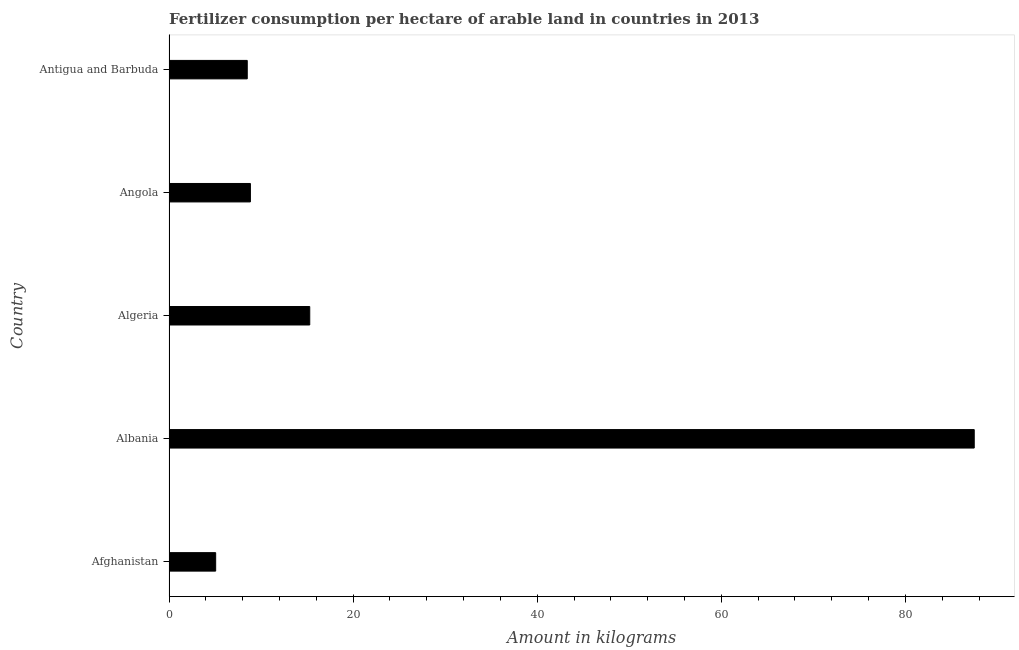Does the graph contain any zero values?
Provide a succinct answer. No. Does the graph contain grids?
Keep it short and to the point. No. What is the title of the graph?
Your answer should be compact. Fertilizer consumption per hectare of arable land in countries in 2013 . What is the label or title of the X-axis?
Ensure brevity in your answer.  Amount in kilograms. What is the amount of fertilizer consumption in Angola?
Your answer should be compact. 8.84. Across all countries, what is the maximum amount of fertilizer consumption?
Your answer should be very brief. 87.48. Across all countries, what is the minimum amount of fertilizer consumption?
Provide a succinct answer. 5.07. In which country was the amount of fertilizer consumption maximum?
Your answer should be very brief. Albania. In which country was the amount of fertilizer consumption minimum?
Give a very brief answer. Afghanistan. What is the sum of the amount of fertilizer consumption?
Make the answer very short. 125.18. What is the difference between the amount of fertilizer consumption in Albania and Angola?
Ensure brevity in your answer.  78.63. What is the average amount of fertilizer consumption per country?
Ensure brevity in your answer.  25.04. What is the median amount of fertilizer consumption?
Your answer should be compact. 8.84. In how many countries, is the amount of fertilizer consumption greater than 44 kg?
Offer a very short reply. 1. What is the ratio of the amount of fertilizer consumption in Afghanistan to that in Angola?
Give a very brief answer. 0.57. What is the difference between the highest and the second highest amount of fertilizer consumption?
Give a very brief answer. 72.19. What is the difference between the highest and the lowest amount of fertilizer consumption?
Offer a terse response. 82.41. In how many countries, is the amount of fertilizer consumption greater than the average amount of fertilizer consumption taken over all countries?
Your response must be concise. 1. How many bars are there?
Offer a terse response. 5. Are all the bars in the graph horizontal?
Provide a succinct answer. Yes. How many countries are there in the graph?
Provide a short and direct response. 5. What is the difference between two consecutive major ticks on the X-axis?
Offer a terse response. 20. Are the values on the major ticks of X-axis written in scientific E-notation?
Give a very brief answer. No. What is the Amount in kilograms of Afghanistan?
Keep it short and to the point. 5.07. What is the Amount in kilograms of Albania?
Provide a succinct answer. 87.48. What is the Amount in kilograms of Algeria?
Your answer should be very brief. 15.29. What is the Amount in kilograms of Angola?
Offer a very short reply. 8.84. What is the Amount in kilograms in Antigua and Barbuda?
Provide a short and direct response. 8.5. What is the difference between the Amount in kilograms in Afghanistan and Albania?
Ensure brevity in your answer.  -82.41. What is the difference between the Amount in kilograms in Afghanistan and Algeria?
Your answer should be compact. -10.22. What is the difference between the Amount in kilograms in Afghanistan and Angola?
Keep it short and to the point. -3.77. What is the difference between the Amount in kilograms in Afghanistan and Antigua and Barbuda?
Give a very brief answer. -3.43. What is the difference between the Amount in kilograms in Albania and Algeria?
Give a very brief answer. 72.19. What is the difference between the Amount in kilograms in Albania and Angola?
Your answer should be compact. 78.63. What is the difference between the Amount in kilograms in Albania and Antigua and Barbuda?
Your answer should be very brief. 78.98. What is the difference between the Amount in kilograms in Algeria and Angola?
Your answer should be very brief. 6.45. What is the difference between the Amount in kilograms in Algeria and Antigua and Barbuda?
Your answer should be compact. 6.79. What is the difference between the Amount in kilograms in Angola and Antigua and Barbuda?
Offer a terse response. 0.34. What is the ratio of the Amount in kilograms in Afghanistan to that in Albania?
Your response must be concise. 0.06. What is the ratio of the Amount in kilograms in Afghanistan to that in Algeria?
Your answer should be very brief. 0.33. What is the ratio of the Amount in kilograms in Afghanistan to that in Angola?
Keep it short and to the point. 0.57. What is the ratio of the Amount in kilograms in Afghanistan to that in Antigua and Barbuda?
Give a very brief answer. 0.6. What is the ratio of the Amount in kilograms in Albania to that in Algeria?
Your answer should be very brief. 5.72. What is the ratio of the Amount in kilograms in Albania to that in Angola?
Make the answer very short. 9.89. What is the ratio of the Amount in kilograms in Albania to that in Antigua and Barbuda?
Keep it short and to the point. 10.29. What is the ratio of the Amount in kilograms in Algeria to that in Angola?
Give a very brief answer. 1.73. What is the ratio of the Amount in kilograms in Algeria to that in Antigua and Barbuda?
Keep it short and to the point. 1.8. What is the ratio of the Amount in kilograms in Angola to that in Antigua and Barbuda?
Your response must be concise. 1.04. 